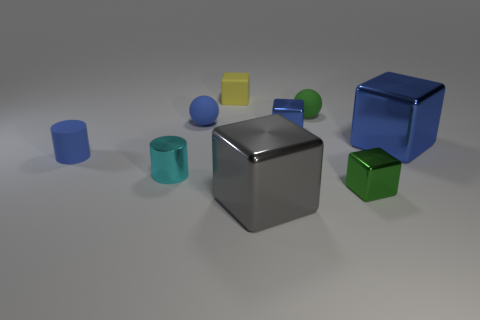Add 1 blue rubber objects. How many objects exist? 10 Subtract all small green shiny blocks. How many blocks are left? 4 Subtract 1 blocks. How many blocks are left? 4 Subtract all balls. How many objects are left? 7 Subtract 1 green cubes. How many objects are left? 8 Subtract all gray cylinders. Subtract all red blocks. How many cylinders are left? 2 Subtract all cyan spheres. How many blue blocks are left? 2 Subtract all small green objects. Subtract all big cyan metallic cylinders. How many objects are left? 7 Add 3 rubber balls. How many rubber balls are left? 5 Add 6 yellow cubes. How many yellow cubes exist? 7 